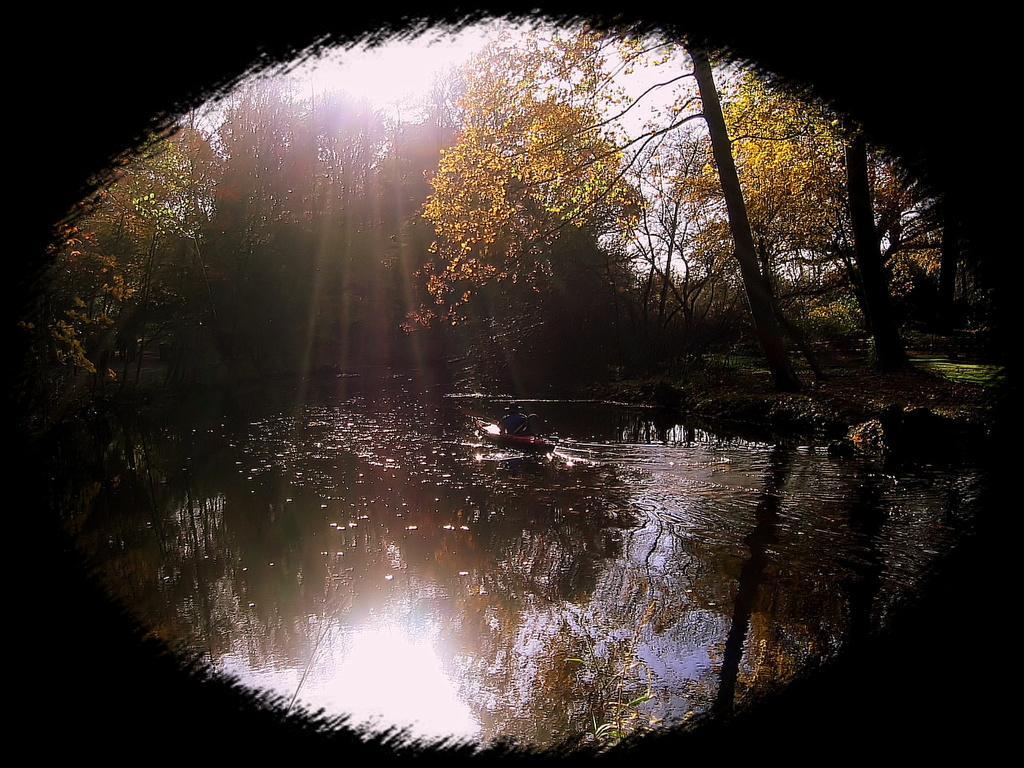Can you describe this image briefly? In this image, we can see some water. We can see a boat with a person is sailing on the water. There are a few trees. We can see the reflection of trees in the water. We can see the sky. 